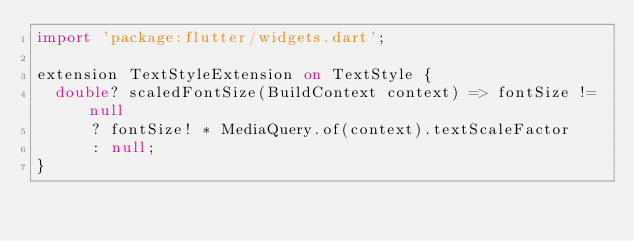Convert code to text. <code><loc_0><loc_0><loc_500><loc_500><_Dart_>import 'package:flutter/widgets.dart';

extension TextStyleExtension on TextStyle {
  double? scaledFontSize(BuildContext context) => fontSize != null
      ? fontSize! * MediaQuery.of(context).textScaleFactor
      : null;
}
</code> 